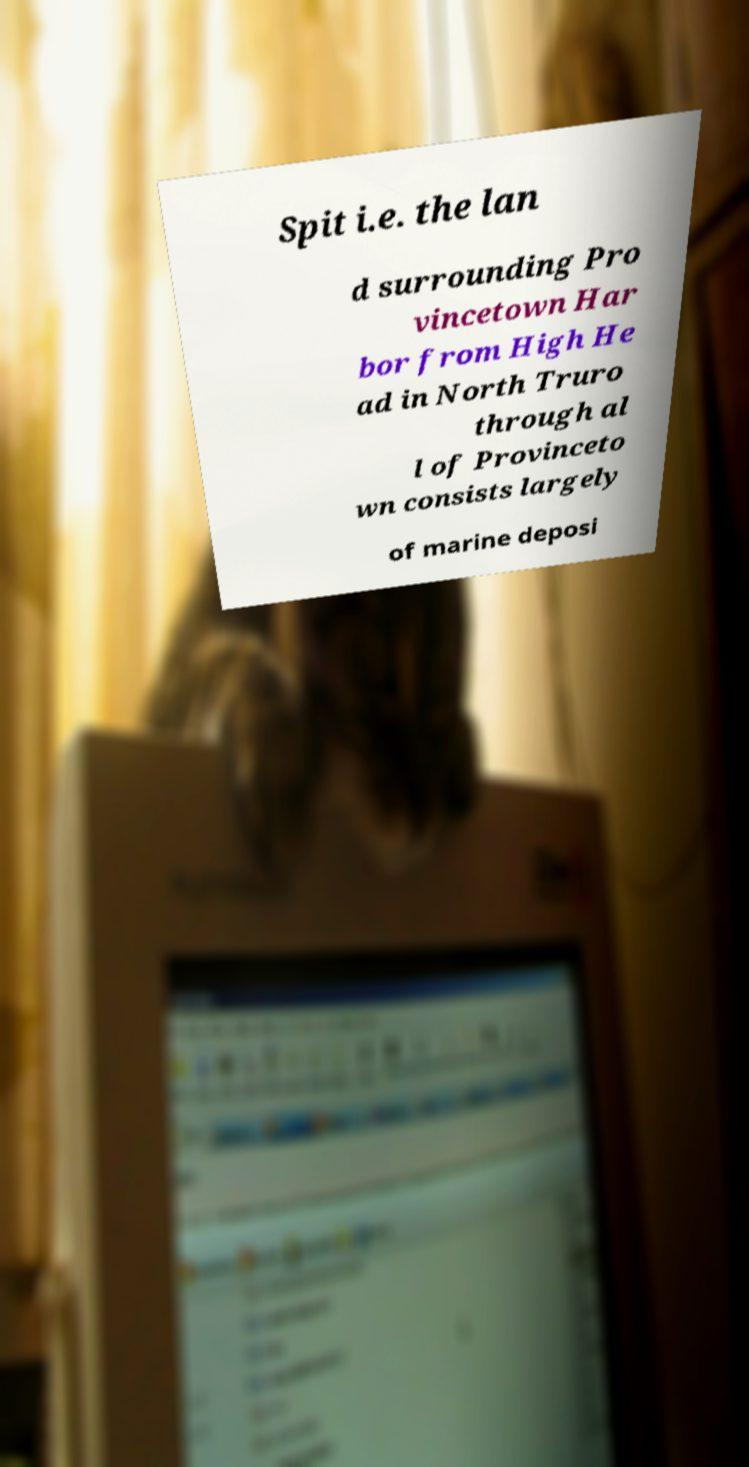For documentation purposes, I need the text within this image transcribed. Could you provide that? Spit i.e. the lan d surrounding Pro vincetown Har bor from High He ad in North Truro through al l of Provinceto wn consists largely of marine deposi 